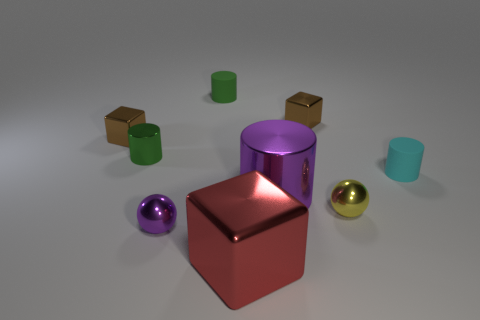Subtract all cubes. How many objects are left? 6 Add 7 big purple cylinders. How many big purple cylinders are left? 8 Add 3 brown rubber cylinders. How many brown rubber cylinders exist? 3 Subtract 1 purple balls. How many objects are left? 8 Subtract all brown things. Subtract all tiny brown things. How many objects are left? 5 